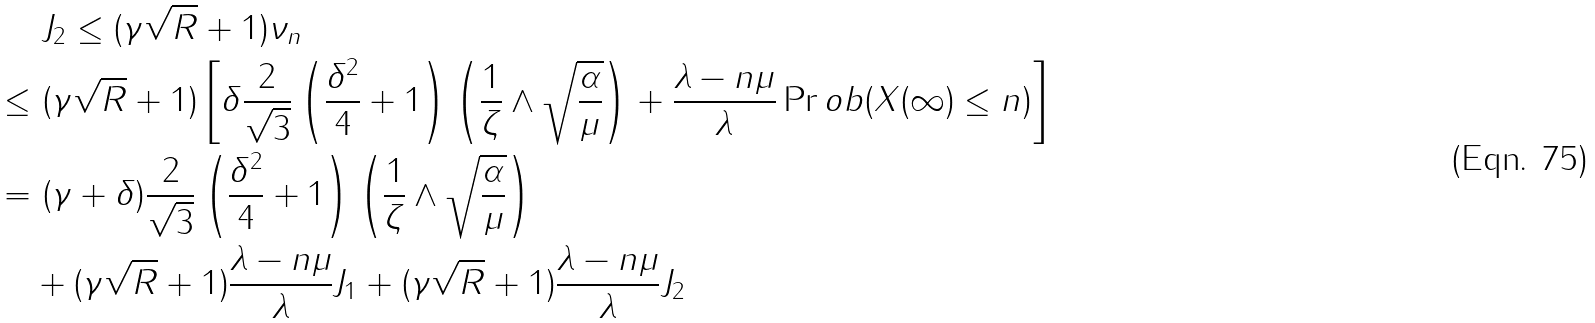Convert formula to latex. <formula><loc_0><loc_0><loc_500><loc_500>& \ J _ { 2 } \leq ( \gamma \sqrt { R } + 1 ) \nu _ { n } \\ \leq & \ ( \gamma \sqrt { R } + 1 ) \left [ \delta \frac { 2 } { \sqrt { 3 } } \left ( \frac { \delta ^ { 2 } } { 4 } + 1 \right ) \left ( \frac { 1 } { \zeta } \wedge \sqrt { \frac { \alpha } { \mu } } \right ) + \frac { \lambda - n \mu } { \lambda } \Pr o b ( X ( \infty ) \leq n ) \right ] \\ = & \ ( \gamma + \delta ) \frac { 2 } { \sqrt { 3 } } \left ( \frac { \delta ^ { 2 } } { 4 } + 1 \right ) \left ( \frac { 1 } { \zeta } \wedge \sqrt { \frac { \alpha } { \mu } } \right ) \\ & + ( \gamma \sqrt { R } + 1 ) \frac { \lambda - n \mu } { \lambda } J _ { 1 } + ( \gamma \sqrt { R } + 1 ) \frac { \lambda - n \mu } { \lambda } J _ { 2 }</formula> 